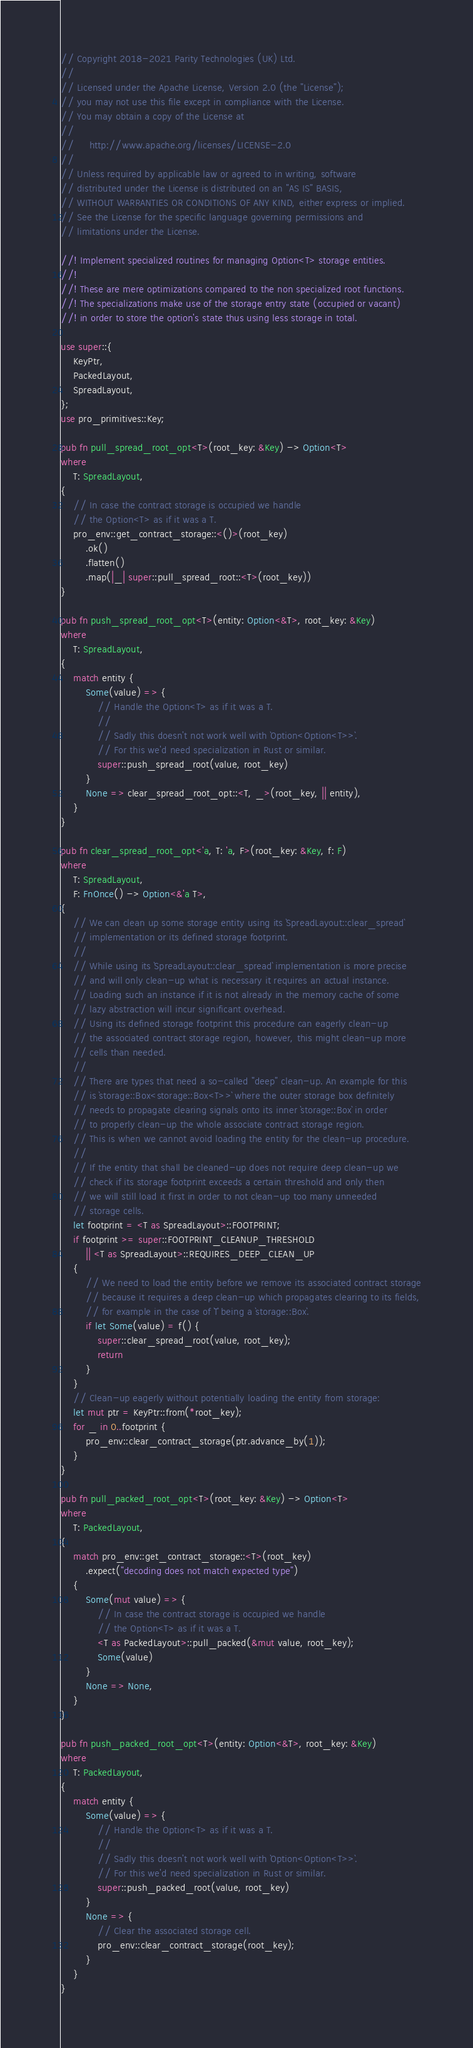<code> <loc_0><loc_0><loc_500><loc_500><_Rust_>// Copyright 2018-2021 Parity Technologies (UK) Ltd.
//
// Licensed under the Apache License, Version 2.0 (the "License");
// you may not use this file except in compliance with the License.
// You may obtain a copy of the License at
//
//     http://www.apache.org/licenses/LICENSE-2.0
//
// Unless required by applicable law or agreed to in writing, software
// distributed under the License is distributed on an "AS IS" BASIS,
// WITHOUT WARRANTIES OR CONDITIONS OF ANY KIND, either express or implied.
// See the License for the specific language governing permissions and
// limitations under the License.

//! Implement specialized routines for managing Option<T> storage entities.
//!
//! These are mere optimizations compared to the non specialized root functions.
//! The specializations make use of the storage entry state (occupied or vacant)
//! in order to store the option's state thus using less storage in total.

use super::{
    KeyPtr,
    PackedLayout,
    SpreadLayout,
};
use pro_primitives::Key;

pub fn pull_spread_root_opt<T>(root_key: &Key) -> Option<T>
where
    T: SpreadLayout,
{
    // In case the contract storage is occupied we handle
    // the Option<T> as if it was a T.
    pro_env::get_contract_storage::<()>(root_key)
        .ok()
        .flatten()
        .map(|_| super::pull_spread_root::<T>(root_key))
}

pub fn push_spread_root_opt<T>(entity: Option<&T>, root_key: &Key)
where
    T: SpreadLayout,
{
    match entity {
        Some(value) => {
            // Handle the Option<T> as if it was a T.
            //
            // Sadly this doesn't not work well with `Option<Option<T>>`.
            // For this we'd need specialization in Rust or similar.
            super::push_spread_root(value, root_key)
        }
        None => clear_spread_root_opt::<T, _>(root_key, || entity),
    }
}

pub fn clear_spread_root_opt<'a, T: 'a, F>(root_key: &Key, f: F)
where
    T: SpreadLayout,
    F: FnOnce() -> Option<&'a T>,
{
    // We can clean up some storage entity using its `SpreadLayout::clear_spread`
    // implementation or its defined storage footprint.
    //
    // While using its `SpreadLayout::clear_spread` implementation is more precise
    // and will only clean-up what is necessary it requires an actual instance.
    // Loading such an instance if it is not already in the memory cache of some
    // lazy abstraction will incur significant overhead.
    // Using its defined storage footprint this procedure can eagerly clean-up
    // the associated contract storage region, however, this might clean-up more
    // cells than needed.
    //
    // There are types that need a so-called "deep" clean-up. An example for this
    // is `storage::Box<storage::Box<T>>` where the outer storage box definitely
    // needs to propagate clearing signals onto its inner `storage::Box` in order
    // to properly clean-up the whole associate contract storage region.
    // This is when we cannot avoid loading the entity for the clean-up procedure.
    //
    // If the entity that shall be cleaned-up does not require deep clean-up we
    // check if its storage footprint exceeds a certain threshold and only then
    // we will still load it first in order to not clean-up too many unneeded
    // storage cells.
    let footprint = <T as SpreadLayout>::FOOTPRINT;
    if footprint >= super::FOOTPRINT_CLEANUP_THRESHOLD
        || <T as SpreadLayout>::REQUIRES_DEEP_CLEAN_UP
    {
        // We need to load the entity before we remove its associated contract storage
        // because it requires a deep clean-up which propagates clearing to its fields,
        // for example in the case of `T` being a `storage::Box`.
        if let Some(value) = f() {
            super::clear_spread_root(value, root_key);
            return
        }
    }
    // Clean-up eagerly without potentially loading the entity from storage:
    let mut ptr = KeyPtr::from(*root_key);
    for _ in 0..footprint {
        pro_env::clear_contract_storage(ptr.advance_by(1));
    }
}

pub fn pull_packed_root_opt<T>(root_key: &Key) -> Option<T>
where
    T: PackedLayout,
{
    match pro_env::get_contract_storage::<T>(root_key)
        .expect("decoding does not match expected type")
    {
        Some(mut value) => {
            // In case the contract storage is occupied we handle
            // the Option<T> as if it was a T.
            <T as PackedLayout>::pull_packed(&mut value, root_key);
            Some(value)
        }
        None => None,
    }
}

pub fn push_packed_root_opt<T>(entity: Option<&T>, root_key: &Key)
where
    T: PackedLayout,
{
    match entity {
        Some(value) => {
            // Handle the Option<T> as if it was a T.
            //
            // Sadly this doesn't not work well with `Option<Option<T>>`.
            // For this we'd need specialization in Rust or similar.
            super::push_packed_root(value, root_key)
        }
        None => {
            // Clear the associated storage cell.
            pro_env::clear_contract_storage(root_key);
        }
    }
}
</code> 